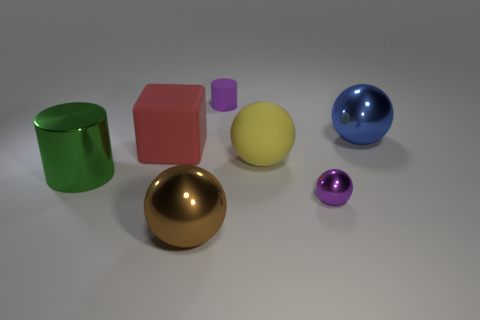Subtract all gray spheres. Subtract all gray blocks. How many spheres are left? 4 Add 2 big blue matte cylinders. How many objects exist? 9 Subtract all cylinders. How many objects are left? 5 Subtract 0 gray cylinders. How many objects are left? 7 Subtract all yellow rubber things. Subtract all big red rubber blocks. How many objects are left? 5 Add 1 tiny purple matte objects. How many tiny purple matte objects are left? 2 Add 5 metallic things. How many metallic things exist? 9 